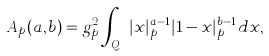<formula> <loc_0><loc_0><loc_500><loc_500>A _ { p } ( a , b ) = g _ { p } ^ { 2 } \int _ { { Q } _ { p } } | x | _ { p } ^ { a - 1 } | 1 - x | _ { p } ^ { b - 1 } d x ,</formula> 